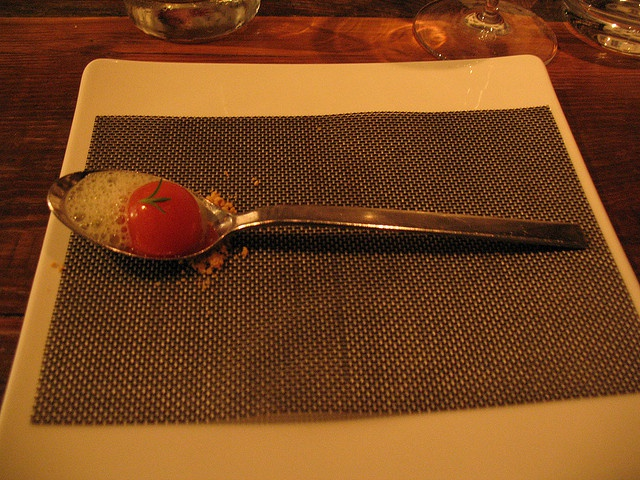Describe the objects in this image and their specific colors. I can see dining table in black, maroon, and brown tones, spoon in black, maroon, and brown tones, wine glass in black, maroon, brown, and red tones, bowl in black, maroon, and brown tones, and bowl in black, maroon, and brown tones in this image. 